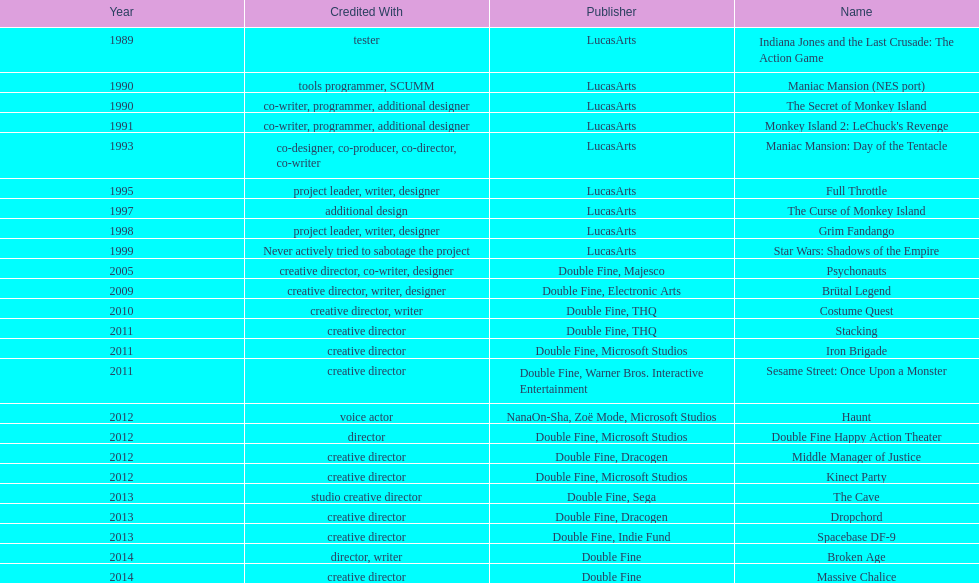How many games were credited with a creative director? 11. Would you be able to parse every entry in this table? {'header': ['Year', 'Credited With', 'Publisher', 'Name'], 'rows': [['1989', 'tester', 'LucasArts', 'Indiana Jones and the Last Crusade: The Action Game'], ['1990', 'tools programmer, SCUMM', 'LucasArts', 'Maniac Mansion (NES port)'], ['1990', 'co-writer, programmer, additional designer', 'LucasArts', 'The Secret of Monkey Island'], ['1991', 'co-writer, programmer, additional designer', 'LucasArts', "Monkey Island 2: LeChuck's Revenge"], ['1993', 'co-designer, co-producer, co-director, co-writer', 'LucasArts', 'Maniac Mansion: Day of the Tentacle'], ['1995', 'project leader, writer, designer', 'LucasArts', 'Full Throttle'], ['1997', 'additional design', 'LucasArts', 'The Curse of Monkey Island'], ['1998', 'project leader, writer, designer', 'LucasArts', 'Grim Fandango'], ['1999', 'Never actively tried to sabotage the project', 'LucasArts', 'Star Wars: Shadows of the Empire'], ['2005', 'creative director, co-writer, designer', 'Double Fine, Majesco', 'Psychonauts'], ['2009', 'creative director, writer, designer', 'Double Fine, Electronic Arts', 'Brütal Legend'], ['2010', 'creative director, writer', 'Double Fine, THQ', 'Costume Quest'], ['2011', 'creative director', 'Double Fine, THQ', 'Stacking'], ['2011', 'creative director', 'Double Fine, Microsoft Studios', 'Iron Brigade'], ['2011', 'creative director', 'Double Fine, Warner Bros. Interactive Entertainment', 'Sesame Street: Once Upon a Monster'], ['2012', 'voice actor', 'NanaOn-Sha, Zoë Mode, Microsoft Studios', 'Haunt'], ['2012', 'director', 'Double Fine, Microsoft Studios', 'Double Fine Happy Action Theater'], ['2012', 'creative director', 'Double Fine, Dracogen', 'Middle Manager of Justice'], ['2012', 'creative director', 'Double Fine, Microsoft Studios', 'Kinect Party'], ['2013', 'studio creative director', 'Double Fine, Sega', 'The Cave'], ['2013', 'creative director', 'Double Fine, Dracogen', 'Dropchord'], ['2013', 'creative director', 'Double Fine, Indie Fund', 'Spacebase DF-9'], ['2014', 'director, writer', 'Double Fine', 'Broken Age'], ['2014', 'creative director', 'Double Fine', 'Massive Chalice']]} 